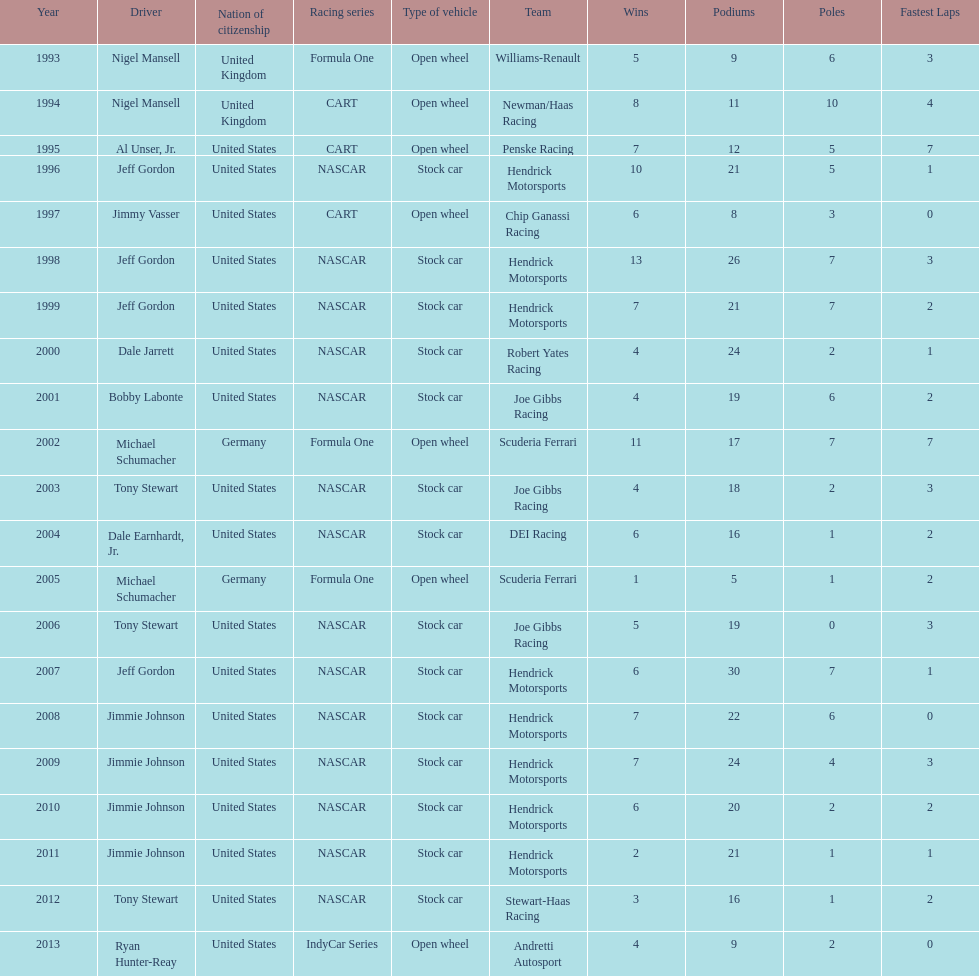Besides nascar, what other racing series have espy-winning drivers come from? Formula One, CART, IndyCar Series. 